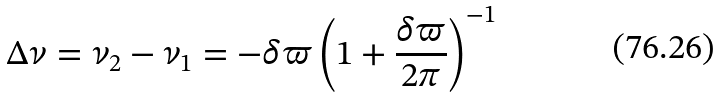Convert formula to latex. <formula><loc_0><loc_0><loc_500><loc_500>\Delta \nu = \nu _ { 2 } - \nu _ { 1 } = - \delta \varpi \left ( 1 + \frac { \delta \varpi } { 2 \pi } \right ) ^ { - 1 }</formula> 